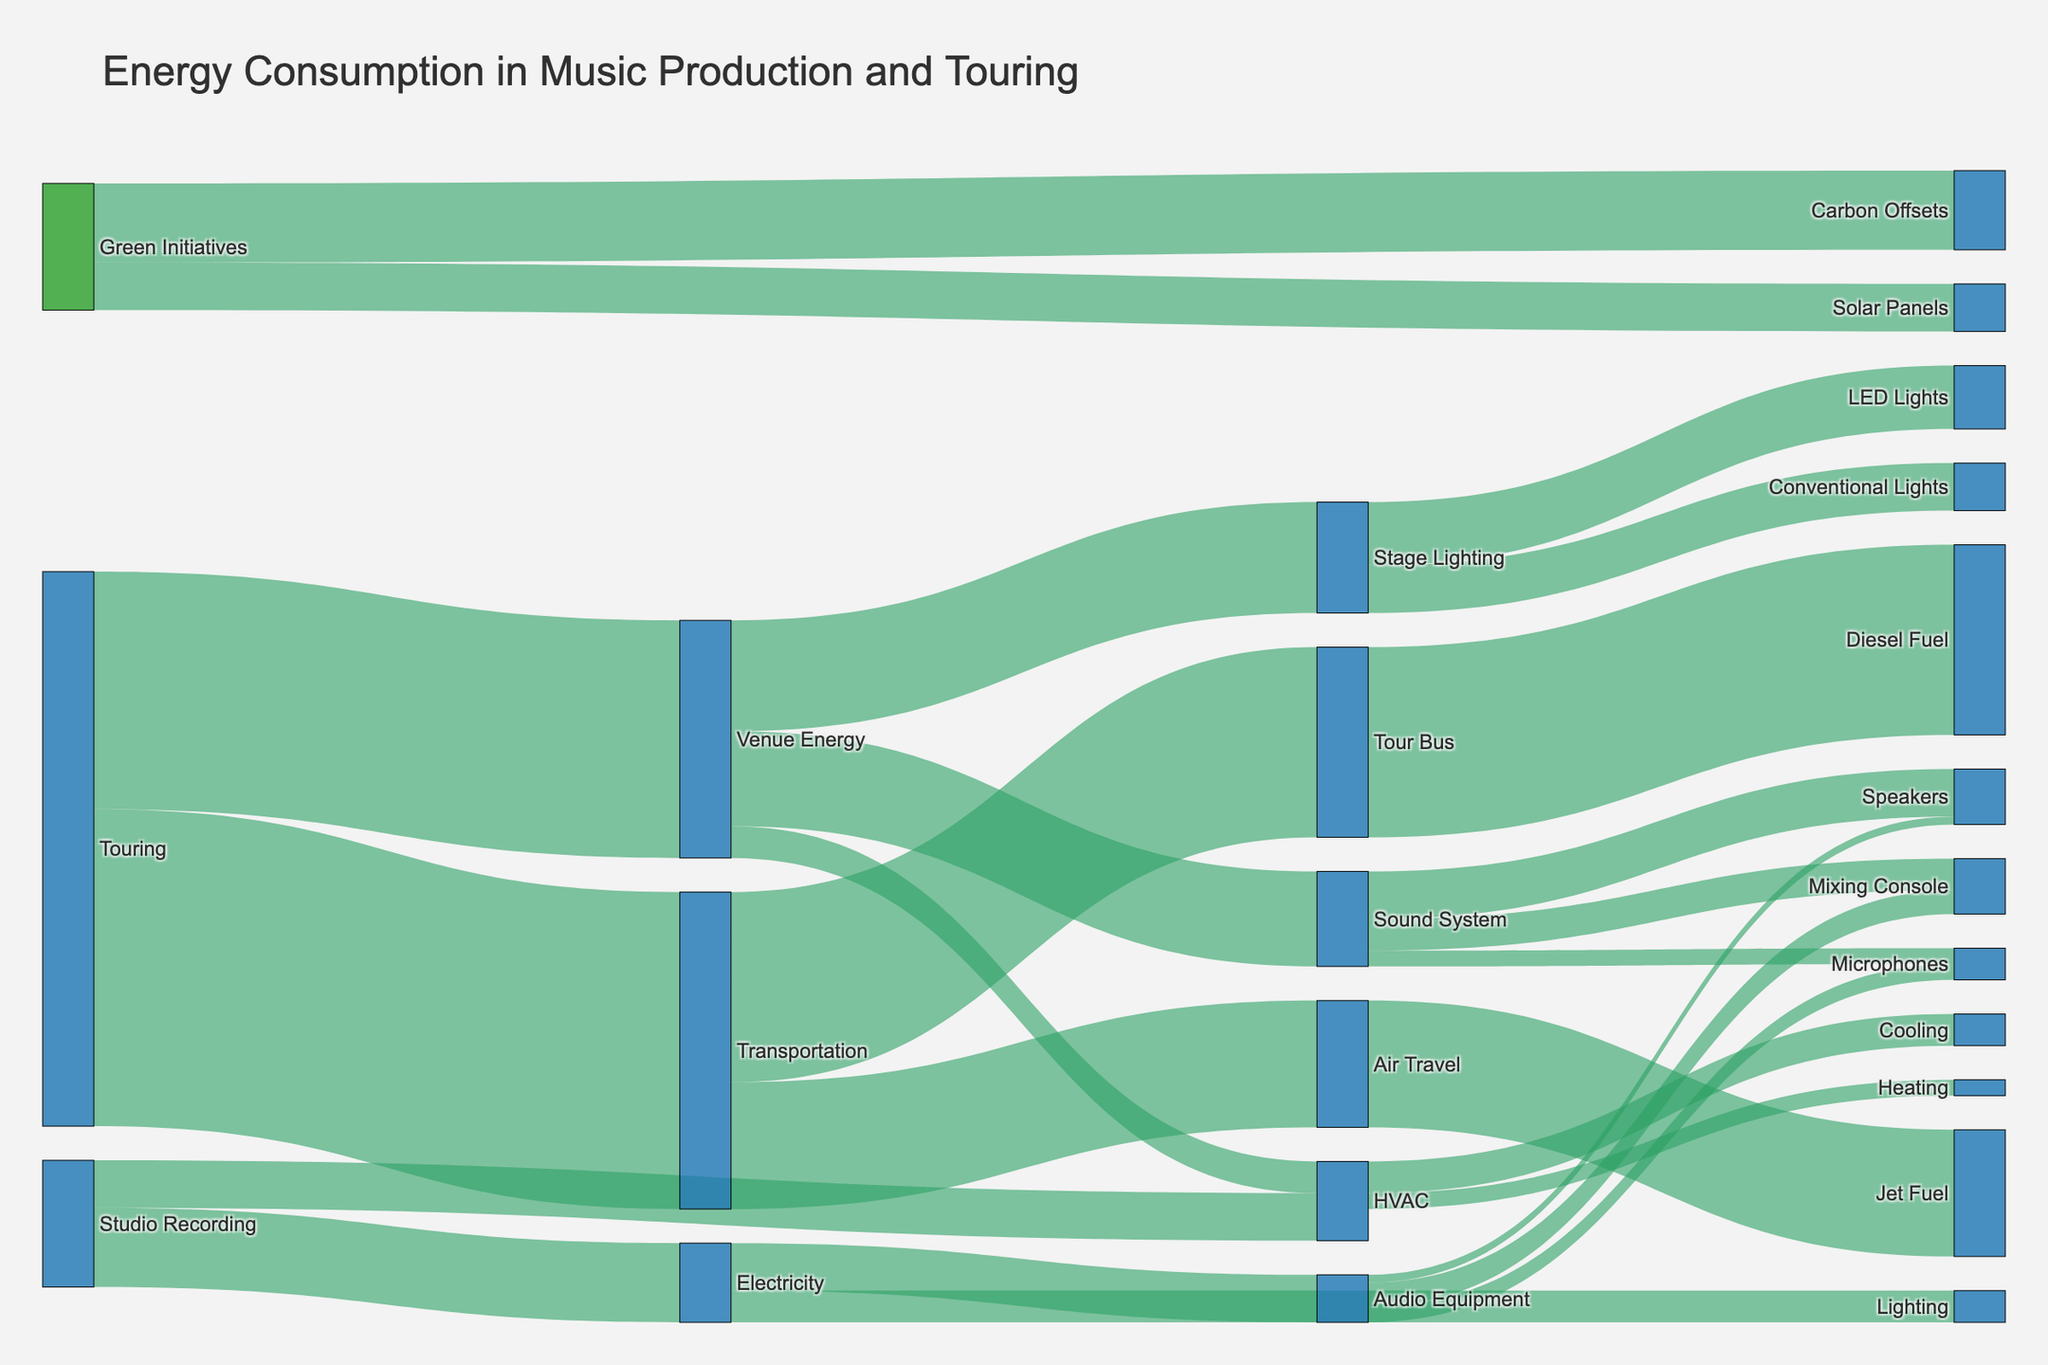What's the title of the figure? The title of the figure is located at the top and usually summarizes the main topic or purpose of the visualization. Here, it indicates the focus on energy consumption in music production and touring.
Answer: Energy Consumption in Music Production and Touring Which node in the diagram has the highest total energy consumption? To find this, look at the nodes with the highest values connected to them. Touring has connections to Transportation and Venue Energy, each with high values (200 and 150).
Answer: Touring How much energy is consumed by stage lighting during touring? Locate the "Stage Lighting" node under "Venue Energy" and see the value of the connection to it, which is from Venue Energy (70).
Answer: 70 Which consumes more energy: HVAC in the studio or HVAC at the venue? Compare the values connected to HVAC in both "Studio Recording" and "Venue Energy". Studio HVAC (30) is split into Cooling (20) and Heating (10), whereas Venue HVAC is (20).
Answer: HVAC in the studio What is the combined energy used by microphones in both the studio and on tour? Add together the values for microphones found under "Audio Equipment" in the studio (10) and "Sound System" at the venue during touring (10). The combined energy is 10 + 10.
Answer: 20 How much energy consumption is offset by green initiatives, including both solar panels and carbon offsets? Add the negative values connected to "Solar Panels" and "Carbon Offsets", which are -20 (Solar Panels to Venue Energy), -30 (Carbon Offsets to Transportation), and -20 (Carbon Offsets to Venue Energy).
Answer: 70 Which type of energy consumption in tours is higher, transportation or venue energy? Compare the values: Transportation (200) and Venue Energy (150). Transportation is higher.
Answer: Transportation What proportion of the total transportation energy is attributed to the tour bus? The transportation total is 200, with the tour bus using 120. Calculate the proportion: 120 / 200 = 0.6, which is 60%.
Answer: 60% How much energy is used by mixing consoles overall, including both studio and touring? Sum the values: in the studio mixing console uses 15, and in touring, it uses 20. The combined energy is 15 + 20.
Answer: 35 What's the net energy impact of green initiatives on venue energy? Sum the impact of Solar Panels (-20) and Carbon Offsets (-20) on Venue Energy, totaling -40. This means that green initiatives reduce venue energy by 40 units.
Answer: -40 